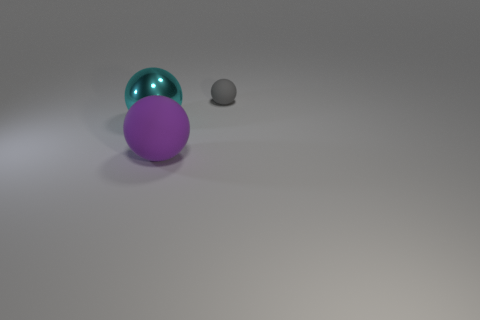Add 2 large cyan matte cubes. How many objects exist? 5 Subtract all gray matte balls. How many balls are left? 2 Subtract 1 spheres. How many spheres are left? 2 Subtract all blue spheres. Subtract all blue cylinders. How many spheres are left? 3 Subtract all small yellow cylinders. Subtract all tiny objects. How many objects are left? 2 Add 1 big purple rubber things. How many big purple rubber things are left? 2 Add 3 small gray shiny blocks. How many small gray shiny blocks exist? 3 Subtract 0 green cylinders. How many objects are left? 3 